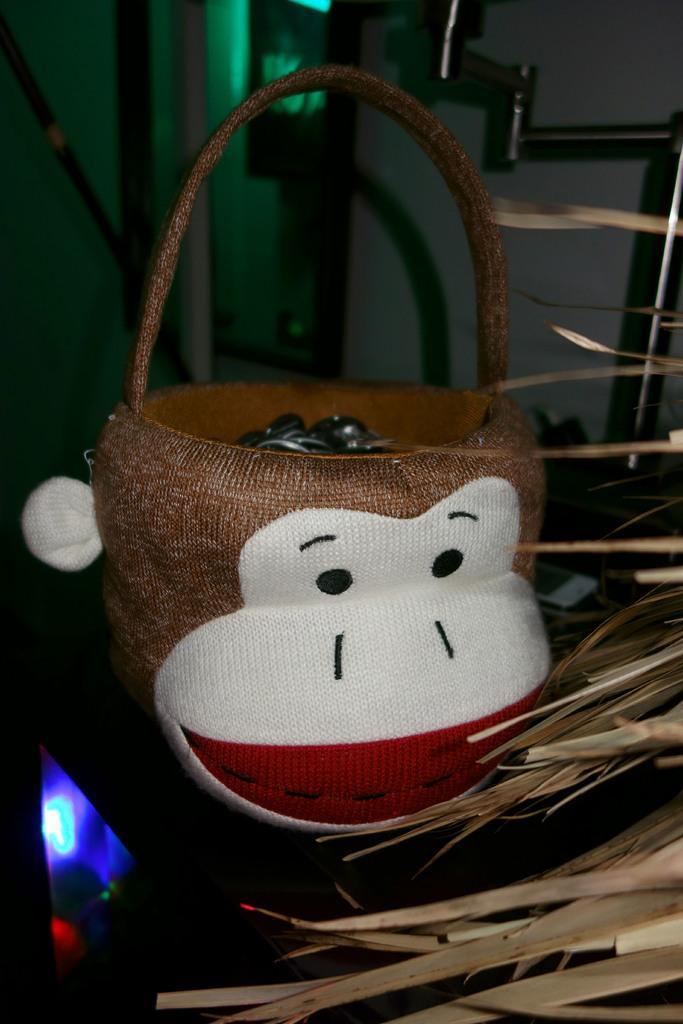How would you summarize this image in a sentence or two? In this picture I see a basket in front and I see the brown color things on the right side of this image and I see the light on the left bottom of this image. In the background I see the wall. 